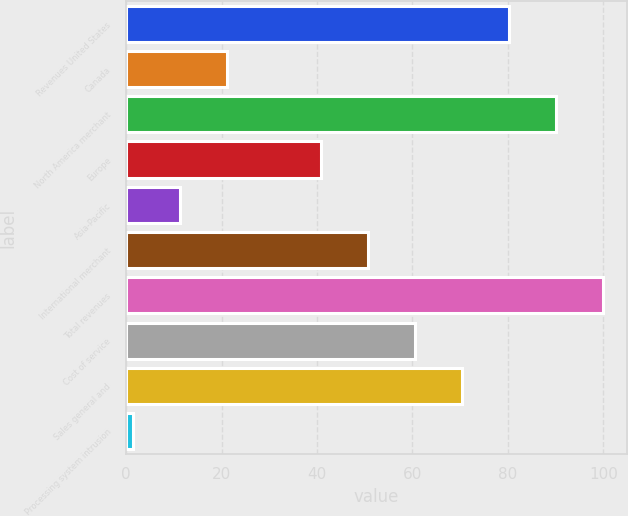Convert chart. <chart><loc_0><loc_0><loc_500><loc_500><bar_chart><fcel>Revenues United States<fcel>Canada<fcel>North America merchant<fcel>Europe<fcel>Asia-Pacific<fcel>International merchant<fcel>Total revenues<fcel>Cost of service<fcel>Sales general and<fcel>Processing system intrusion<nl><fcel>80.3<fcel>21.2<fcel>90.15<fcel>40.9<fcel>11.35<fcel>50.75<fcel>100<fcel>60.6<fcel>70.45<fcel>1.5<nl></chart> 